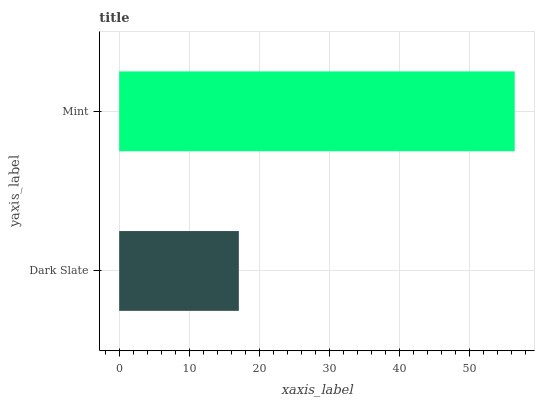Is Dark Slate the minimum?
Answer yes or no. Yes. Is Mint the maximum?
Answer yes or no. Yes. Is Mint the minimum?
Answer yes or no. No. Is Mint greater than Dark Slate?
Answer yes or no. Yes. Is Dark Slate less than Mint?
Answer yes or no. Yes. Is Dark Slate greater than Mint?
Answer yes or no. No. Is Mint less than Dark Slate?
Answer yes or no. No. Is Mint the high median?
Answer yes or no. Yes. Is Dark Slate the low median?
Answer yes or no. Yes. Is Dark Slate the high median?
Answer yes or no. No. Is Mint the low median?
Answer yes or no. No. 